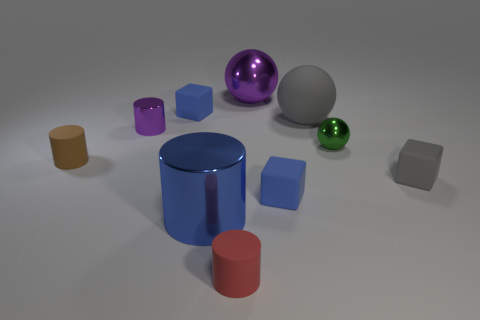There is a metal object right of the gray object that is behind the brown rubber object; what color is it?
Keep it short and to the point. Green. What number of metallic things are either large cylinders or tiny gray cubes?
Ensure brevity in your answer.  1. Is the material of the red thing the same as the small gray block?
Give a very brief answer. Yes. There is a purple object that is right of the large thing that is on the left side of the big purple ball; what is its material?
Your answer should be very brief. Metal. What number of small objects are blue cubes or green things?
Your answer should be compact. 3. How big is the gray rubber cube?
Provide a succinct answer. Small. Is the number of blue matte things behind the brown thing greater than the number of small green metallic cylinders?
Your response must be concise. Yes. Are there an equal number of brown objects that are right of the small red object and things that are left of the small gray matte cube?
Offer a very short reply. No. The block that is on the right side of the large blue cylinder and on the left side of the big matte thing is what color?
Provide a succinct answer. Blue. Is there any other thing that has the same size as the brown cylinder?
Make the answer very short. Yes. 